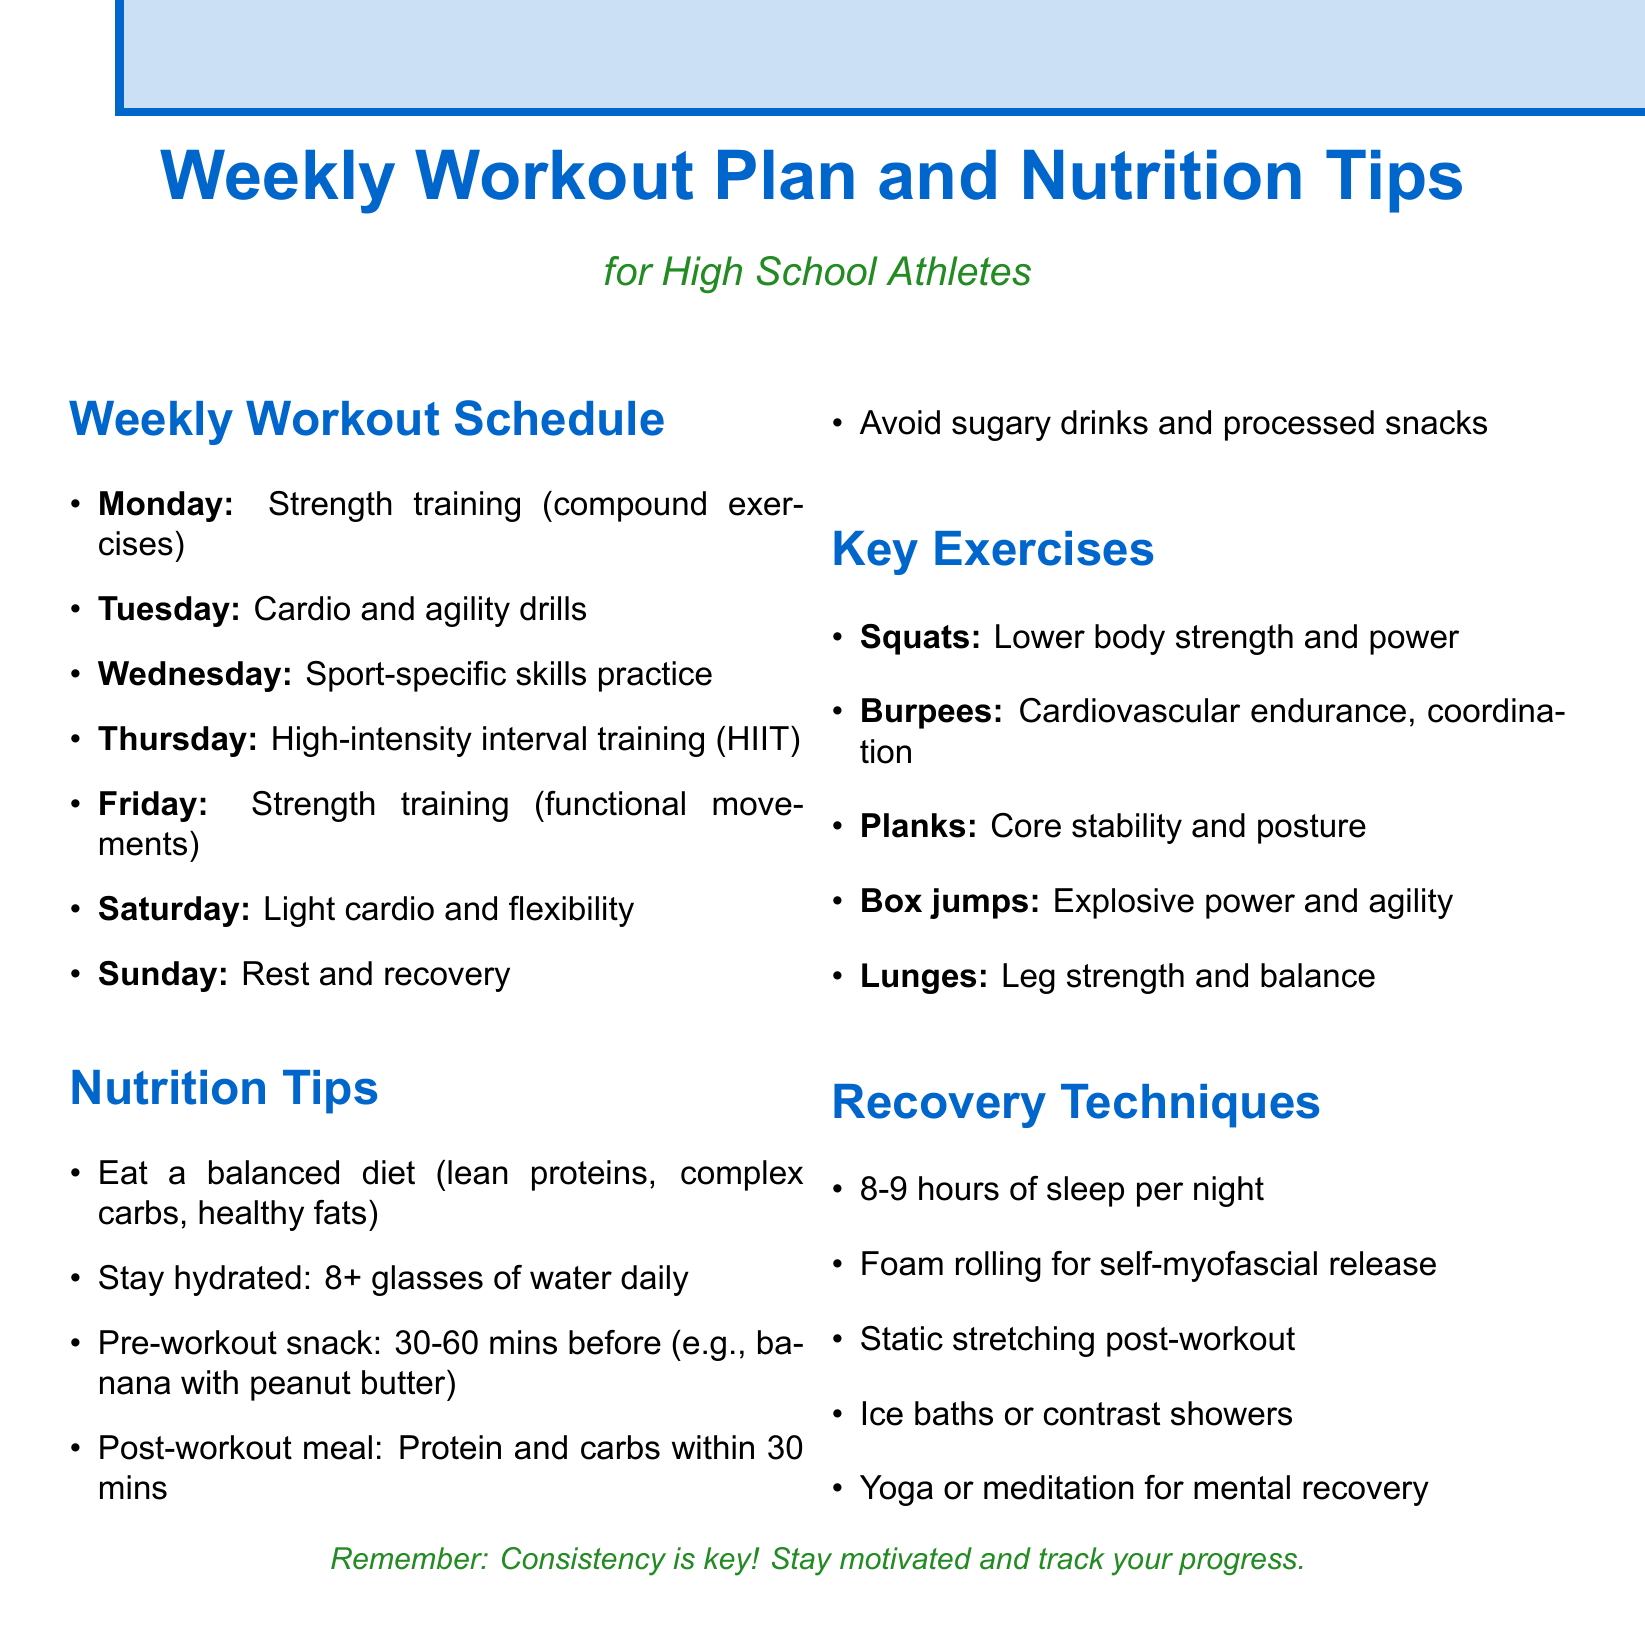What is the first day of the workout schedule? The first day in the weekly workout schedule is Monday.
Answer: Monday What type of training occurs on Thursday? The document specifies that Thursday's workout is high-intensity interval training.
Answer: High-intensity interval training (HIIT) How many hours of sleep should athletes aim for? The document suggests that athletes should get 8-9 hours of sleep per night.
Answer: 8-9 hours What should be consumed 30-60 minutes before exercising? The nutrition tips recommend a pre-workout snack, such as a banana with peanut butter.
Answer: Pre-workout snack Which exercise is highlighted for building lower body strength? Squats are noted in the document as an exercise for building lower body strength and power.
Answer: Squats What is recommended to do after workouts for recovery? The document advises practicing static stretching after workouts for recovery.
Answer: Static stretching What type of drills are included on Tuesday? Tuesday includes cardio and agility drills in the workout schedule.
Answer: Cardio and agility drills Which recovery technique involves self-myofascial release? Foam rolling is recommended in the document for self-myofascial release.
Answer: Foam rolling What is the main focus of the workout on Saturday? The schedule indicates that Saturday focuses on light cardio and flexibility.
Answer: Light cardio and flexibility 